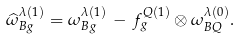Convert formula to latex. <formula><loc_0><loc_0><loc_500><loc_500>\widehat { \omega } _ { B g } ^ { \lambda ( 1 ) } = \omega _ { B g } ^ { \lambda ( 1 ) } \, - \, f _ { g } ^ { Q ( 1 ) } \otimes \omega _ { B Q } ^ { \lambda ( 0 ) } .</formula> 